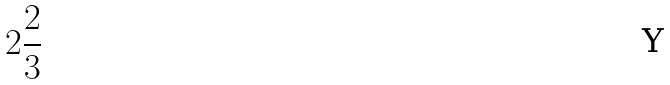Convert formula to latex. <formula><loc_0><loc_0><loc_500><loc_500>2 \frac { 2 } { 3 }</formula> 